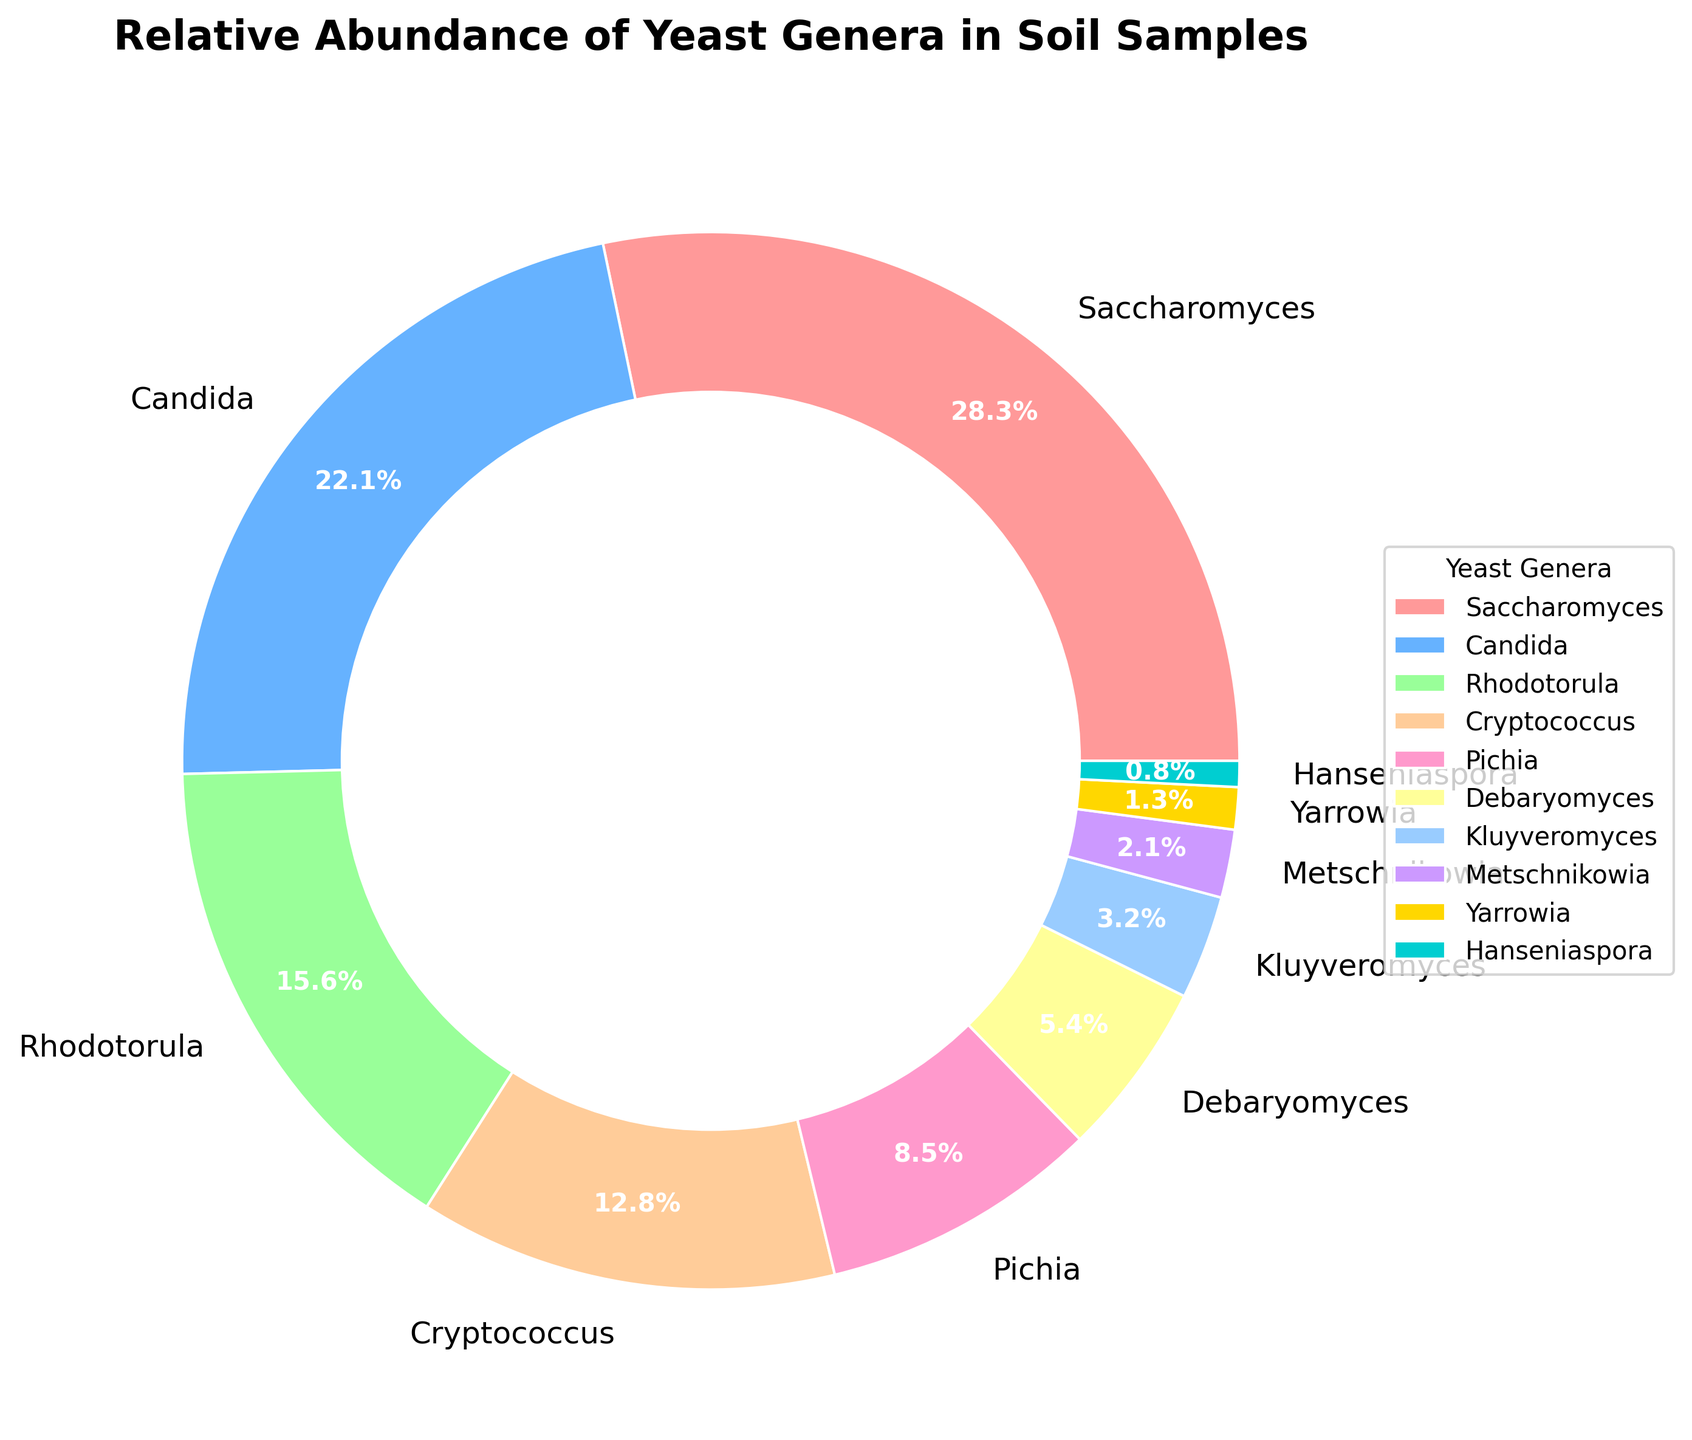What percentage of the total relative abundance is accounted for by Saccharomyces and Candida combined? To find this, add the relative abundance of Saccharomyces (28.5%) and Candida (22.3%). The combined percentage is 28.5 + 22.3 = 50.8%.
Answer: 50.8% Which two genera have the closest relative abundance values? Compare the relative abundance values for all genera to identify the two that are closest to each other. Rhodotorula has 15.7% and Cryptococcus has 12.9%, so the difference is 15.7 - 12.9 = 2.8. No other pairs have a smaller difference.
Answer: Rhodotorula and Cryptococcus How many genera have a relative abundance greater than 10%? Identify the genera with more than 10% relative abundance: Saccharomyces (28.5%), Candida (22.3%), Rhodotorula (15.7%), and Cryptococcus (12.9%). There are four such genera.
Answer: 4 Which genus has the lowest relative abundance, and what is its percentage? Identify the genus with the smallest percentage by comparing relative abundances. Hanseniaspora has the lowest at 0.8%.
Answer: Hanseniaspora, 0.8% What is the cumulative relative abundance of the genera with less than 5% individual abundance? Add up the relative abundances of Debaryomyces (5.4%, not less than 5%), Kluyveromyces (3.2%), Metschnikowia (2.1%), Yarrowia (1.3%), and Hanseniaspora (0.8%). The total is 3.2 + 2.1 + 1.3 + 0.8 = 7.4%.
Answer: 7.4% Which genus is represented by the slice with the bluish color, and what is its relative abundance? The bluish color is associated with Candida. Its relative abundance is 22.3%.
Answer: Candida, 22.3% What is the difference in relative abundance between the genus with the highest and the genus with the lowest relative abundance? Subtract the lowest relative abundance (Hanseniaspora, 0.8%) from the highest (Saccharomyces, 28.5%). The difference is 28.5 - 0.8 = 27.7.
Answer: 27.7 If we consider only the top three most abundant genera, what percentage of the total do they represent? Add the relative abundances of the top three genera: Saccharomyces (28.5%), Candida (22.3%), and Rhodotorula (15.7%). The total is 28.5 + 22.3 + 15.7 = 66.5%.
Answer: 66.5% What is the ratio of the relative abundance of Pichia to Kluyveromyces? Divide Pichia's relative abundance (8.6%) by Kluyveromyces' relative abundance (3.2%). The ratio is 8.6 / 3.2 = 2.6875.
Answer: 2.6875 Does the genus Saccharomyces have more than double the relative abundance of Cryptococcus? Compare twice the relative abundance of Cryptococcus (12.9 * 2 = 25.8) with the abundance of Saccharomyces (28.5%). Since 28.5 > 25.8, the answer is yes.
Answer: Yes 